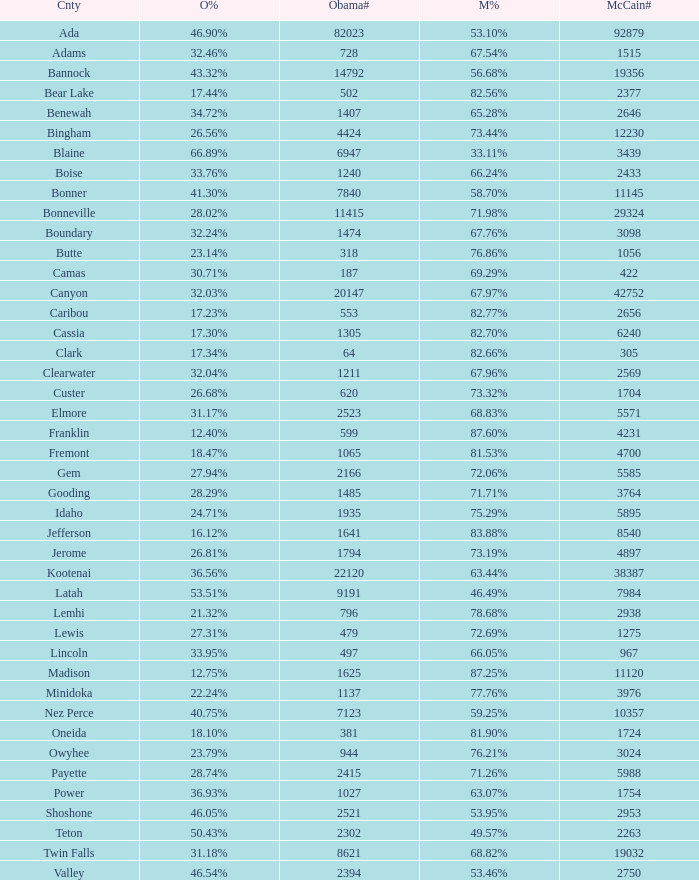For Gem County, what was the Obama vote percentage? 27.94%. 